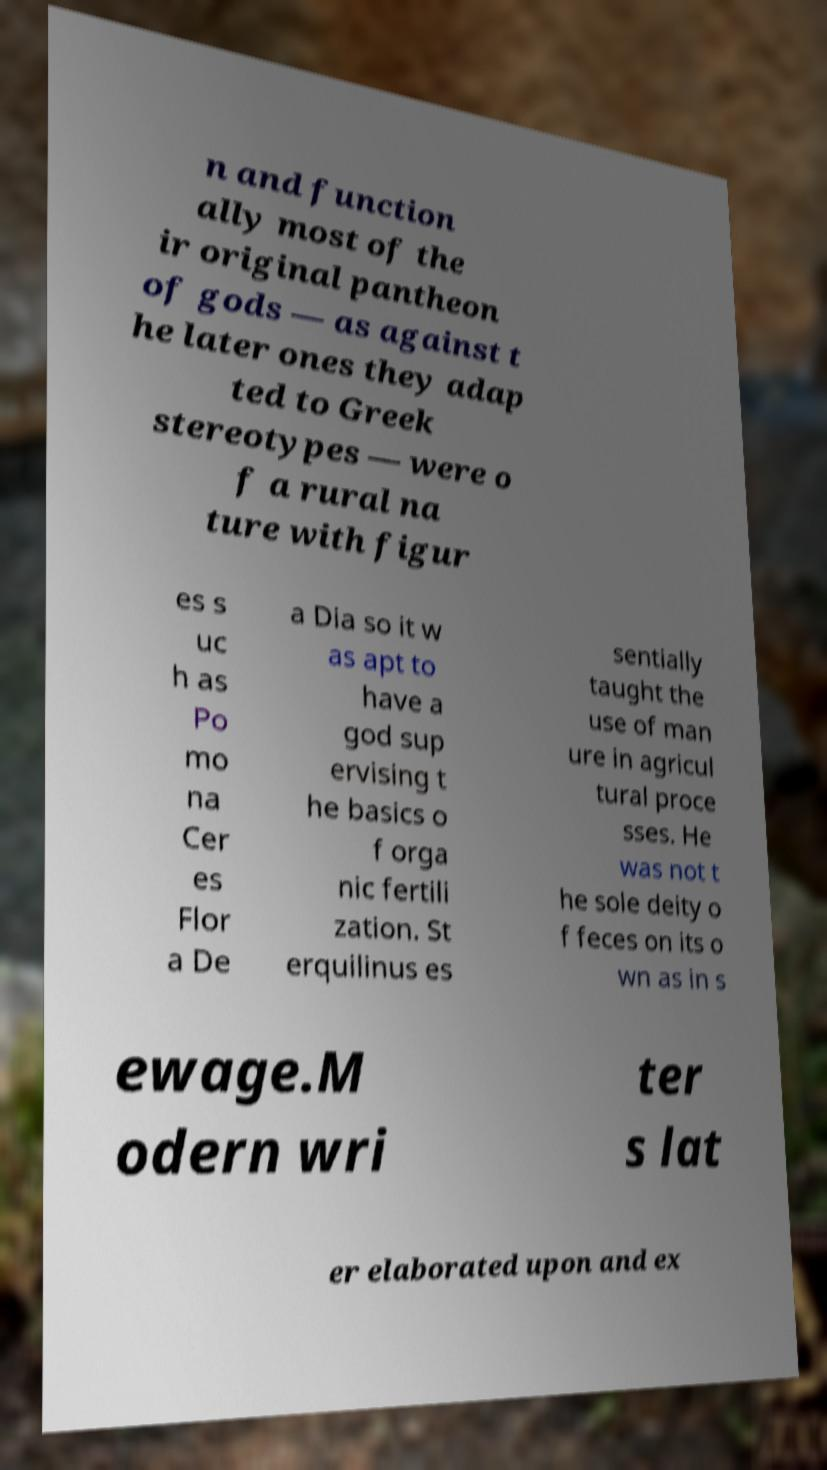Please read and relay the text visible in this image. What does it say? n and function ally most of the ir original pantheon of gods — as against t he later ones they adap ted to Greek stereotypes — were o f a rural na ture with figur es s uc h as Po mo na Cer es Flor a De a Dia so it w as apt to have a god sup ervising t he basics o f orga nic fertili zation. St erquilinus es sentially taught the use of man ure in agricul tural proce sses. He was not t he sole deity o f feces on its o wn as in s ewage.M odern wri ter s lat er elaborated upon and ex 